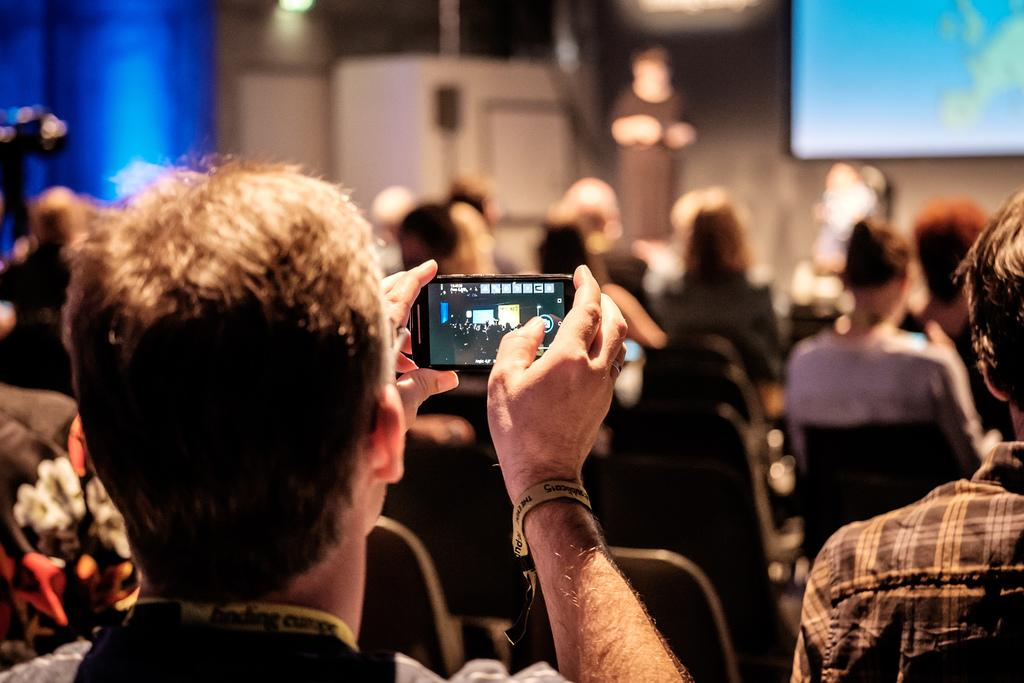What is the man in the image doing? The man is capturing video on his cell phone. What is the location of the man in the image? The man is near a stage. What is happening on the stage? Something is happening on the stage, but the specific event cannot be determined from the image. Who is the audience in the image looking at? The audience is looking at the stage. What type of rainstorm is occurring during the performance on the stage? There is no rainstorm present in the image; it is an indoor event. What color are the stockings worn by the performer on the stage? There is no performer or stockings mentioned in the image. 